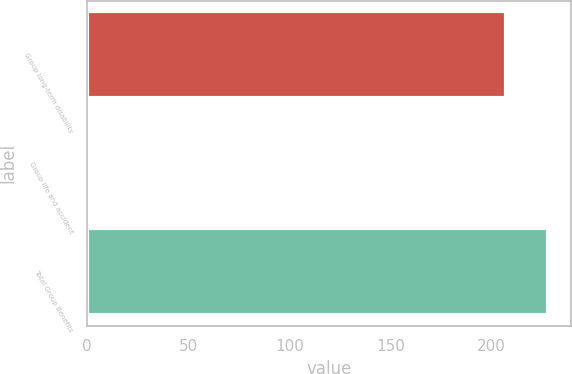<chart> <loc_0><loc_0><loc_500><loc_500><bar_chart><fcel>Group long-term disability<fcel>Group life and accident<fcel>Total Group Benefits<nl><fcel>207<fcel>1<fcel>227.8<nl></chart> 